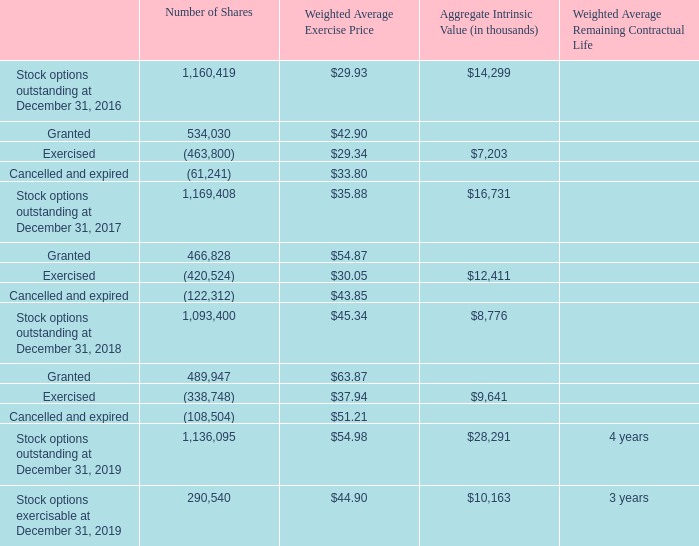Stock Option Activity - The weighted-average fair value of options granted during the years ended December 31, 2019, 2018 and 2017, as determined under the Black-Scholes-Merton valuation model, was $12.07, $10.42 and $6.75, respectively. Option grants that vested during the years ended December 31, 2019, 2018 and 2017 had a combined fair value of $2.5 million, $1.5 million and $1.7 million, respectively.
The following table summarizes stock option activity for the years ended December 31, 2019, 2018 and 2017:
What were the weighted-average fair value of options granted during the years ended December 31, 2017, 2018, and 2019, respectively? $6.75, $10.42, $12.07. What was the number of stock options that were outstanding at December 31, 2017? 1,169,408. What was the weighted average remaining contractual life of the stock options outstanding as of December 31, 2019? 4 years. What is the total value of stock options outstanding on December 31, 2018? 1,093,400*$45.34 
Answer: 49574756. What is the total price of stock options exercised or canceled and expired during the period between December 31, 2018, and 2019? (338,748*37.94)+(108,504*51.21)
Answer: 18408588.96. What is the ratio of stock options exercisable to outstanding on December 31, 2019? 290,540/1,136,095
Answer: 0.26. 